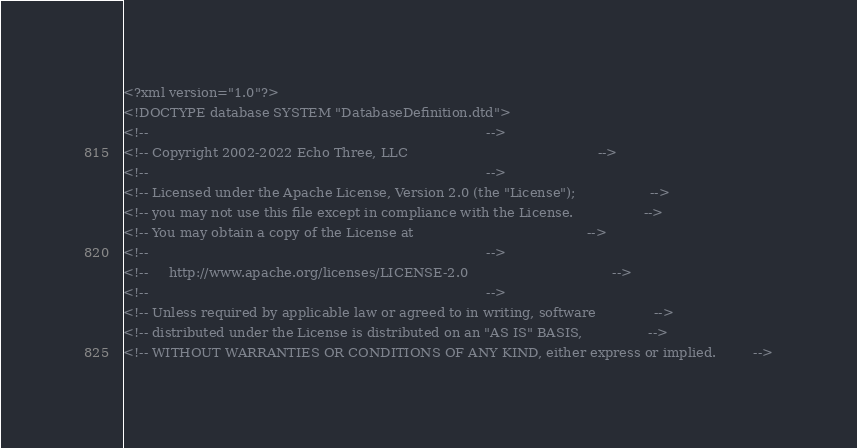Convert code to text. <code><loc_0><loc_0><loc_500><loc_500><_XML_><?xml version="1.0"?>
<!DOCTYPE database SYSTEM "DatabaseDefinition.dtd">
<!--                                                                                  -->
<!-- Copyright 2002-2022 Echo Three, LLC                                              -->
<!--                                                                                  -->
<!-- Licensed under the Apache License, Version 2.0 (the "License");                  -->
<!-- you may not use this file except in compliance with the License.                 -->
<!-- You may obtain a copy of the License at                                          -->
<!--                                                                                  -->
<!--     http://www.apache.org/licenses/LICENSE-2.0                                   -->
<!--                                                                                  -->
<!-- Unless required by applicable law or agreed to in writing, software              -->
<!-- distributed under the License is distributed on an "AS IS" BASIS,                -->
<!-- WITHOUT WARRANTIES OR CONDITIONS OF ANY KIND, either express or implied.         --></code> 